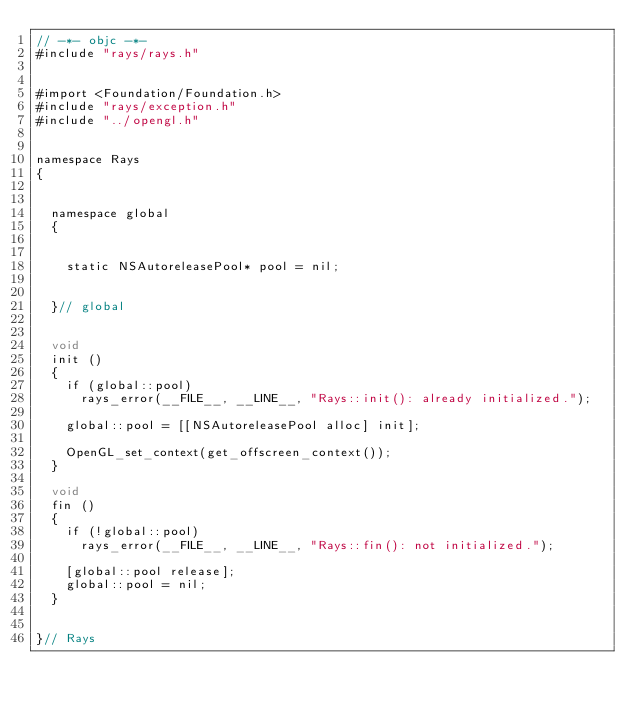Convert code to text. <code><loc_0><loc_0><loc_500><loc_500><_ObjectiveC_>// -*- objc -*-
#include "rays/rays.h"


#import <Foundation/Foundation.h>
#include "rays/exception.h"
#include "../opengl.h"


namespace Rays
{


	namespace global
	{


		static NSAutoreleasePool* pool = nil;


	}// global


	void
	init ()
	{
		if (global::pool)
			rays_error(__FILE__, __LINE__, "Rays::init(): already initialized.");

		global::pool = [[NSAutoreleasePool alloc] init];

		OpenGL_set_context(get_offscreen_context());
	}

	void
	fin ()
	{
		if (!global::pool)
			rays_error(__FILE__, __LINE__, "Rays::fin(): not initialized.");

		[global::pool release];
		global::pool = nil;
	}


}// Rays
</code> 